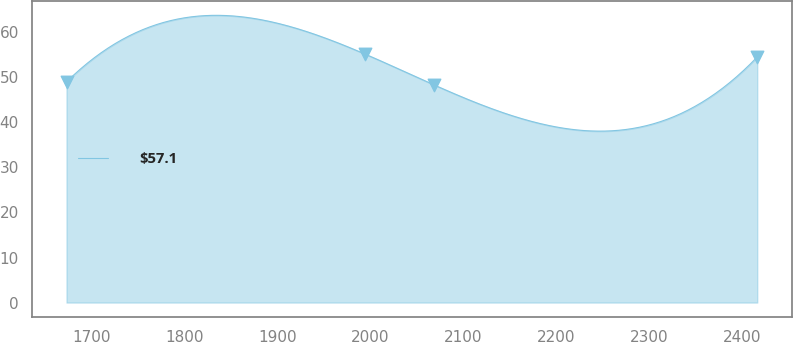<chart> <loc_0><loc_0><loc_500><loc_500><line_chart><ecel><fcel>$57.1<nl><fcel>1672.68<fcel>48.99<nl><fcel>1993.92<fcel>55.18<nl><fcel>2068.29<fcel>48.33<nl><fcel>2416.41<fcel>54.52<nl></chart> 